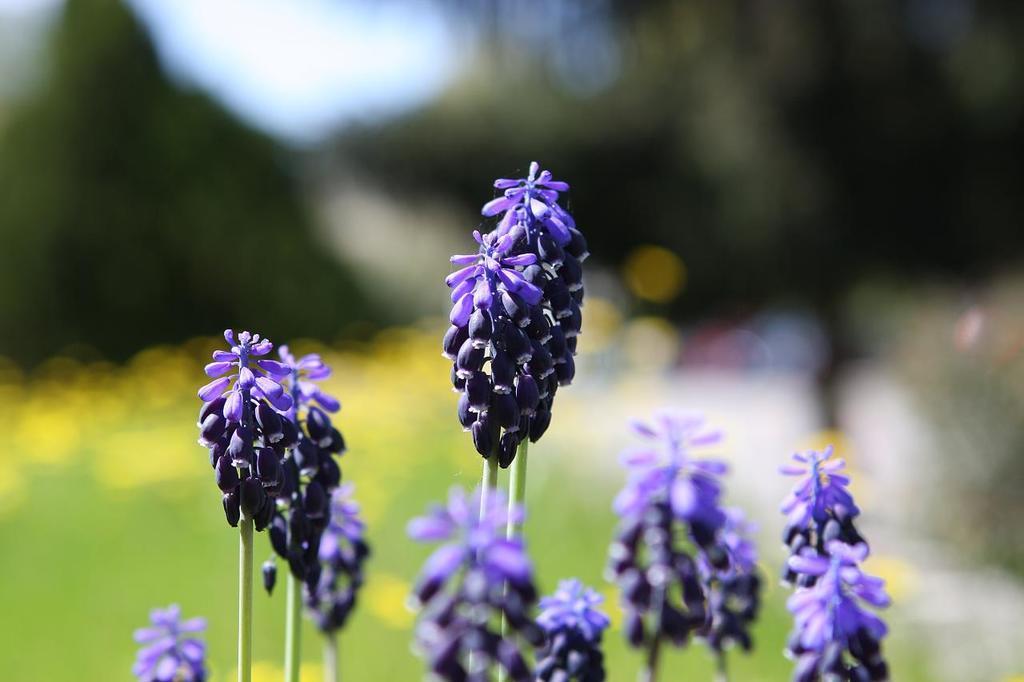How would you summarize this image in a sentence or two? In the image we can see there are many flowers, purple in color and this is a stem of the flower. The background is blurred. 